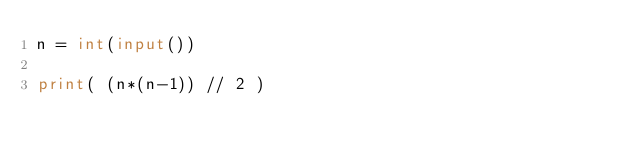Convert code to text. <code><loc_0><loc_0><loc_500><loc_500><_Python_>n = int(input())

print( (n*(n-1)) // 2 )
</code> 